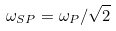<formula> <loc_0><loc_0><loc_500><loc_500>\omega _ { S P } = \omega _ { P } / \sqrt { 2 }</formula> 